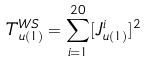<formula> <loc_0><loc_0><loc_500><loc_500>T _ { u ( 1 ) } ^ { W S } = \sum _ { i = 1 } ^ { 2 0 } [ J _ { u ( 1 ) } ^ { i } ] ^ { 2 }</formula> 